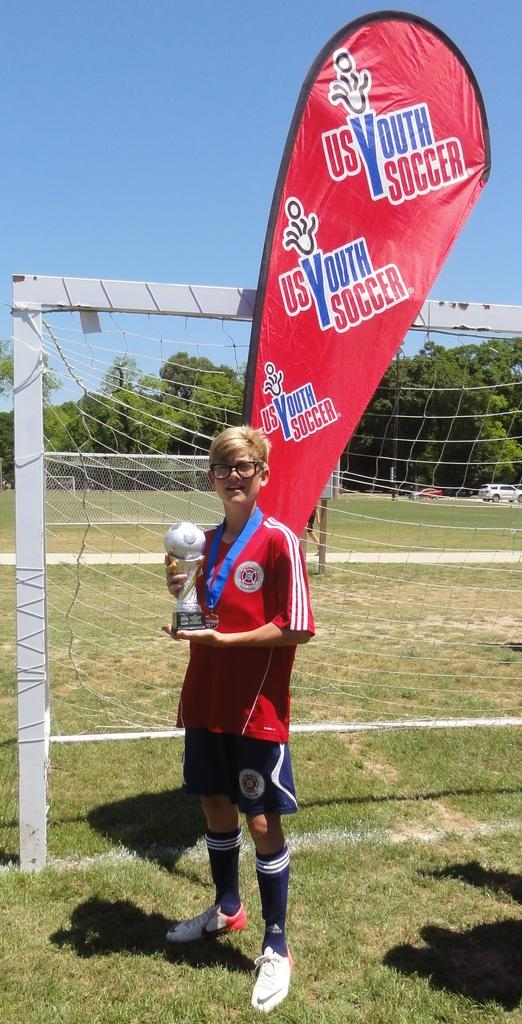Provide a one-sentence caption for the provided image. A young lady proudly holds her youth soccer trophy. 